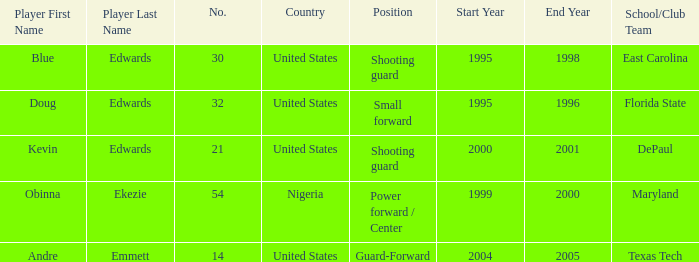Which school/club team did blue edwards play for East Carolina. 